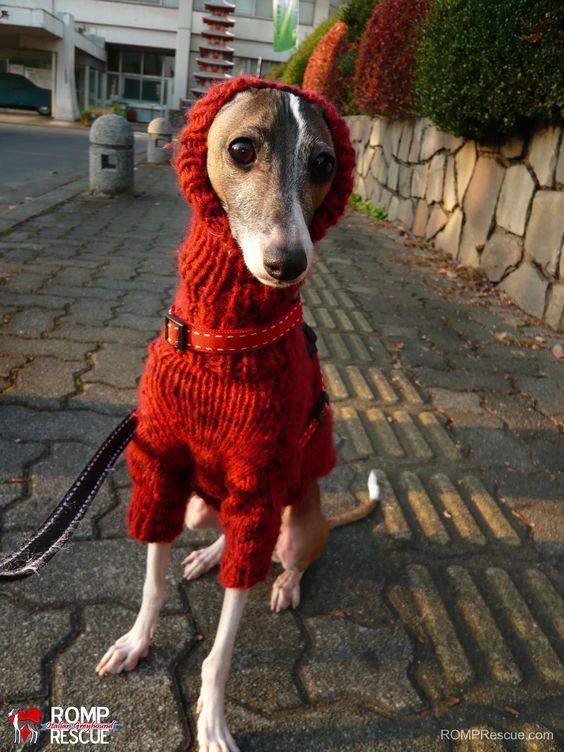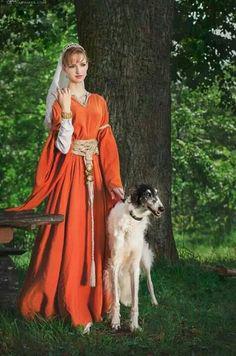The first image is the image on the left, the second image is the image on the right. Assess this claim about the two images: "In image there is a woman dressed in red walking three Russian Wolfhounds in the snow.". Correct or not? Answer yes or no. No. 